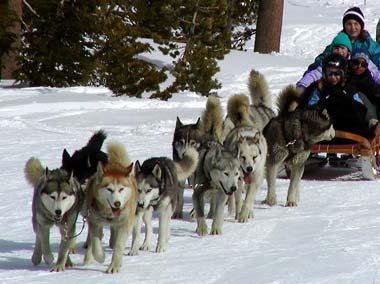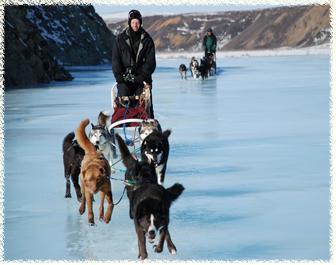The first image is the image on the left, the second image is the image on the right. For the images shown, is this caption "There are trees in the image on the left." true? Answer yes or no. Yes. The first image is the image on the left, the second image is the image on the right. Considering the images on both sides, is "An image shows at least one sled but fewer than 3 dogs." valid? Answer yes or no. No. 